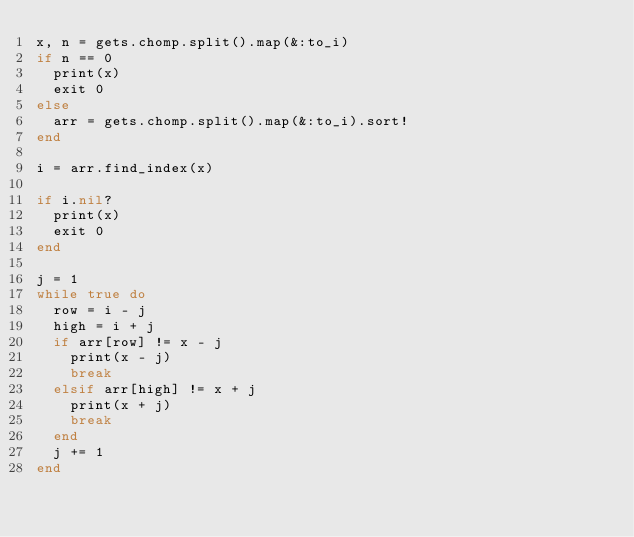<code> <loc_0><loc_0><loc_500><loc_500><_Ruby_>x, n = gets.chomp.split().map(&:to_i)
if n == 0
  print(x)
  exit 0
else
  arr = gets.chomp.split().map(&:to_i).sort!
end

i = arr.find_index(x)

if i.nil?
  print(x)
  exit 0
end

j = 1
while true do
  row = i - j
  high = i + j
  if arr[row] != x - j
    print(x - j)
    break
  elsif arr[high] != x + j
    print(x + j)
    break
  end
  j += 1
end
</code> 